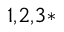Convert formula to latex. <formula><loc_0><loc_0><loc_500><loc_500>^ { 1 , 2 , 3 * }</formula> 